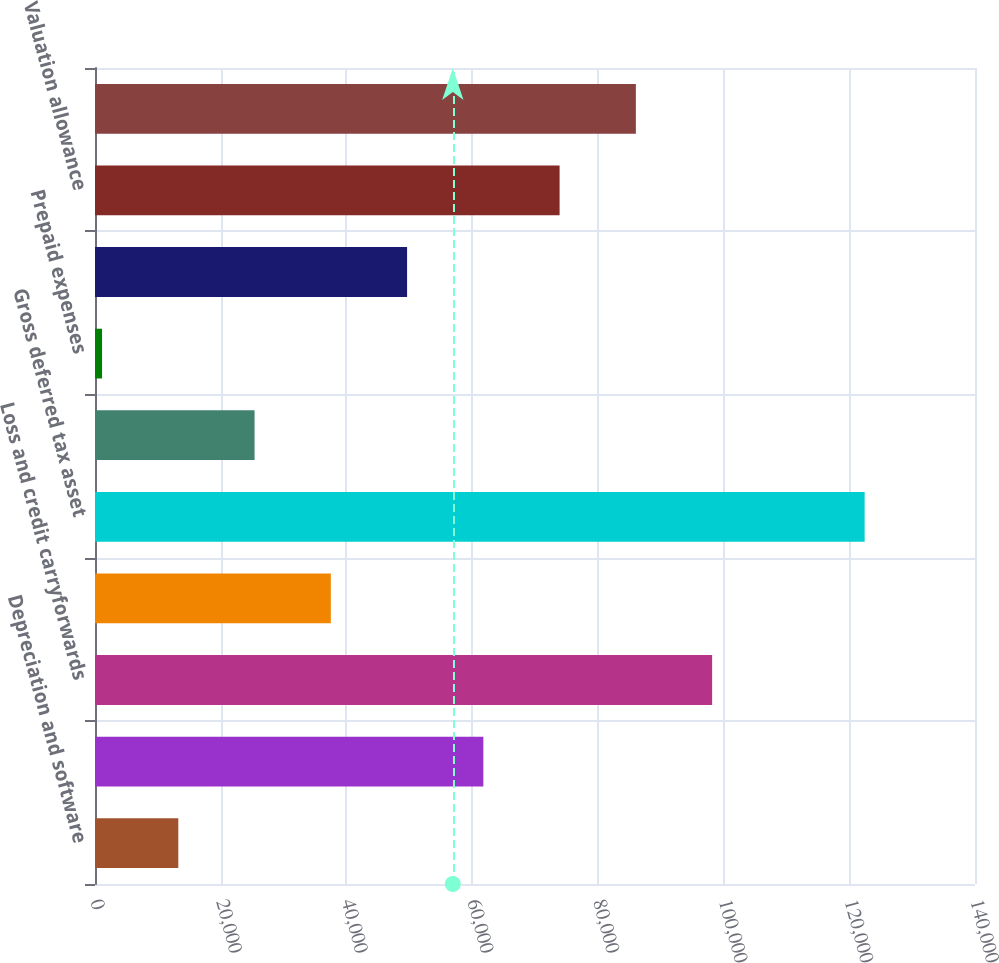Convert chart. <chart><loc_0><loc_0><loc_500><loc_500><bar_chart><fcel>Depreciation and software<fcel>Expense accruals for book<fcel>Loss and credit carryforwards<fcel>Other<fcel>Gross deferred tax asset<fcel>Intangible assets<fcel>Prepaid expenses<fcel>Gross deferred tax liability<fcel>Valuation allowance<fcel>Net deferred tax asset<nl><fcel>13253.2<fcel>61782<fcel>98178.6<fcel>37517.6<fcel>122443<fcel>25385.4<fcel>1121<fcel>49649.8<fcel>73914.2<fcel>86046.4<nl></chart> 